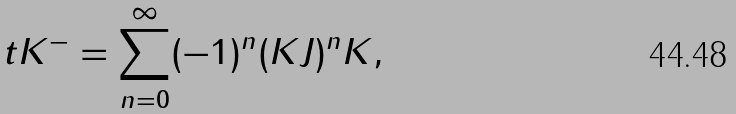Convert formula to latex. <formula><loc_0><loc_0><loc_500><loc_500>\ t { K } ^ { - } = \sum _ { n = 0 } ^ { \infty } ( - 1 ) ^ { n } ( K J ) ^ { n } K ,</formula> 